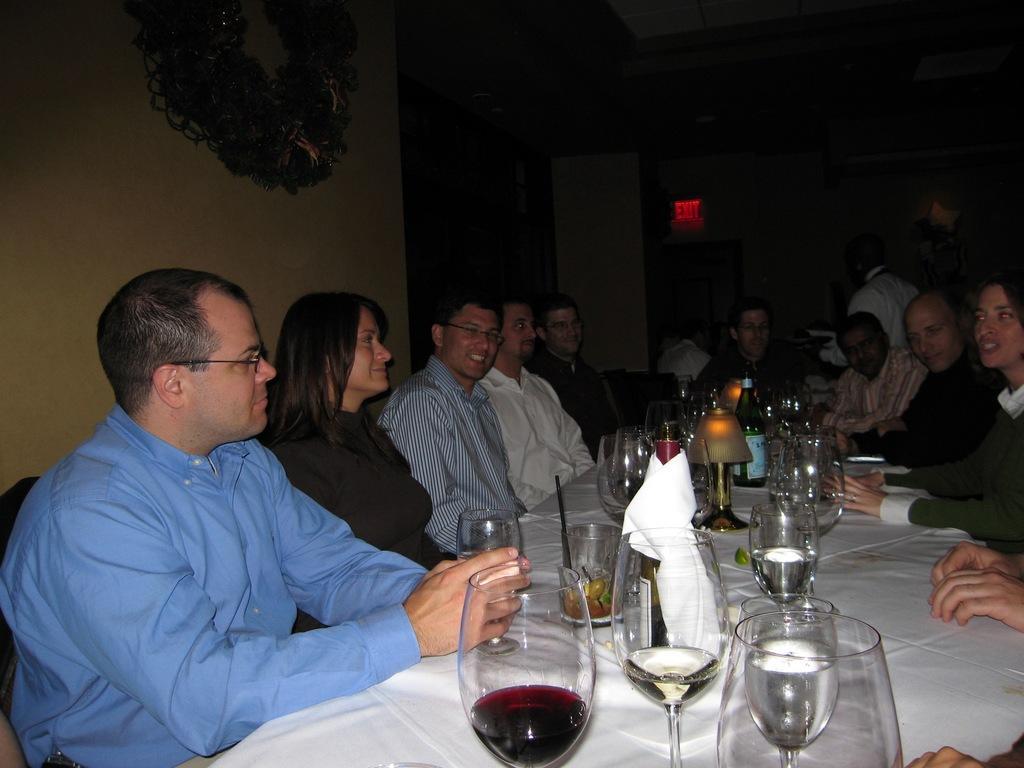Describe this image in one or two sentences. Here group of people are sitting on the chairs around the dining table and there are wine glasses on this table on the left side of an image there is a man wear shirt beside of him there is a woman and in the right side of an image there is a woman is talking. 